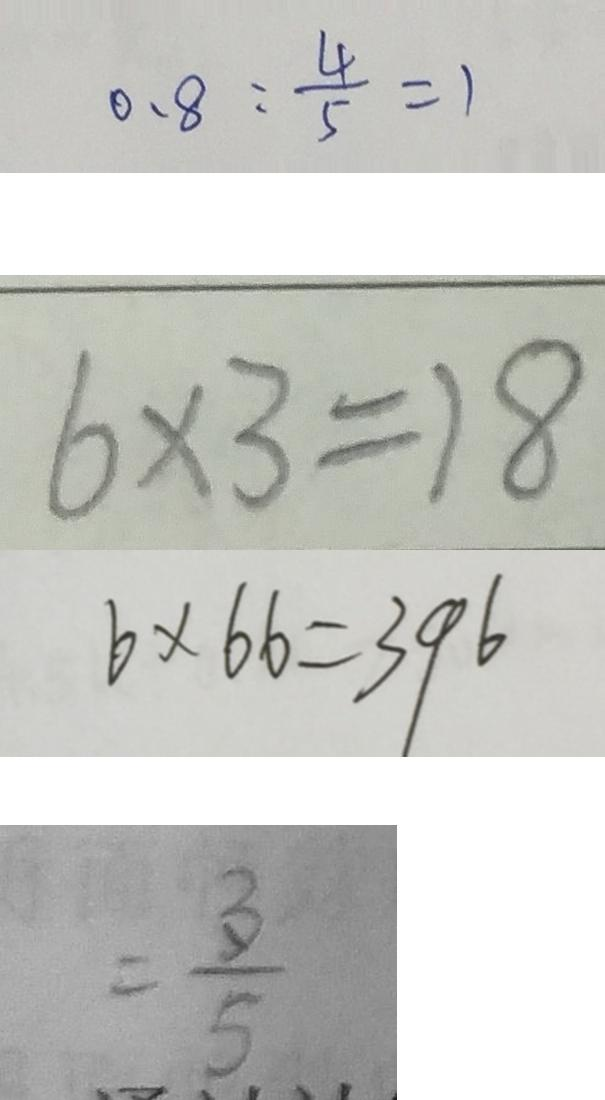<formula> <loc_0><loc_0><loc_500><loc_500>0 . 8 : \frac { 4 } { 5 } = 1 
 6 \times 3 = 1 8 
 6 \times 6 6 = 3 9 6 
 = \frac { 3 } { 5 }</formula> 